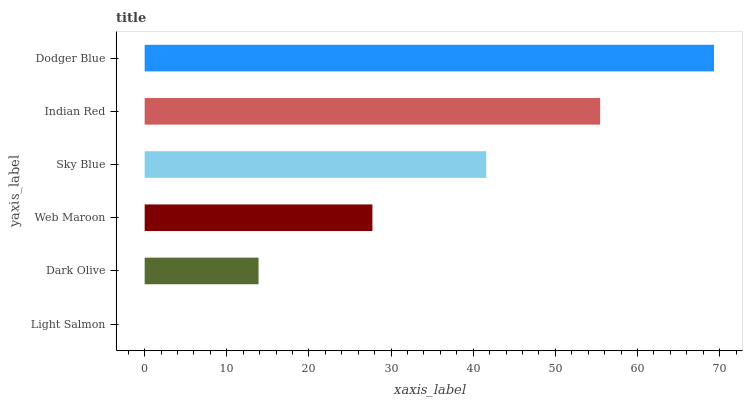Is Light Salmon the minimum?
Answer yes or no. Yes. Is Dodger Blue the maximum?
Answer yes or no. Yes. Is Dark Olive the minimum?
Answer yes or no. No. Is Dark Olive the maximum?
Answer yes or no. No. Is Dark Olive greater than Light Salmon?
Answer yes or no. Yes. Is Light Salmon less than Dark Olive?
Answer yes or no. Yes. Is Light Salmon greater than Dark Olive?
Answer yes or no. No. Is Dark Olive less than Light Salmon?
Answer yes or no. No. Is Sky Blue the high median?
Answer yes or no. Yes. Is Web Maroon the low median?
Answer yes or no. Yes. Is Dodger Blue the high median?
Answer yes or no. No. Is Sky Blue the low median?
Answer yes or no. No. 